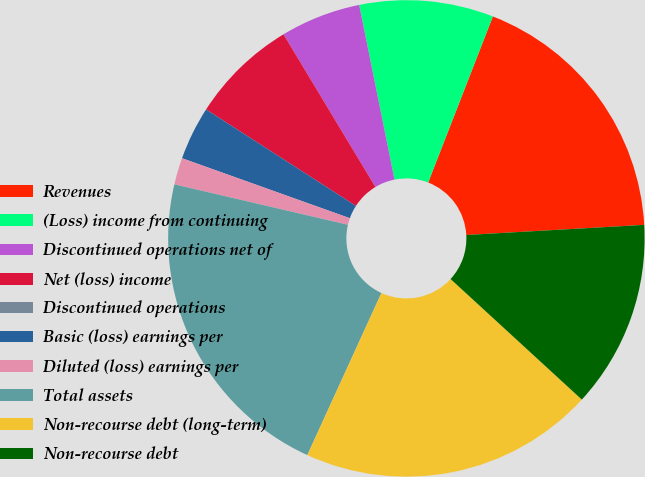<chart> <loc_0><loc_0><loc_500><loc_500><pie_chart><fcel>Revenues<fcel>(Loss) income from continuing<fcel>Discontinued operations net of<fcel>Net (loss) income<fcel>Discontinued operations<fcel>Basic (loss) earnings per<fcel>Diluted (loss) earnings per<fcel>Total assets<fcel>Non-recourse debt (long-term)<fcel>Non-recourse debt<nl><fcel>18.18%<fcel>9.09%<fcel>5.45%<fcel>7.27%<fcel>0.0%<fcel>3.64%<fcel>1.82%<fcel>21.82%<fcel>20.0%<fcel>12.73%<nl></chart> 